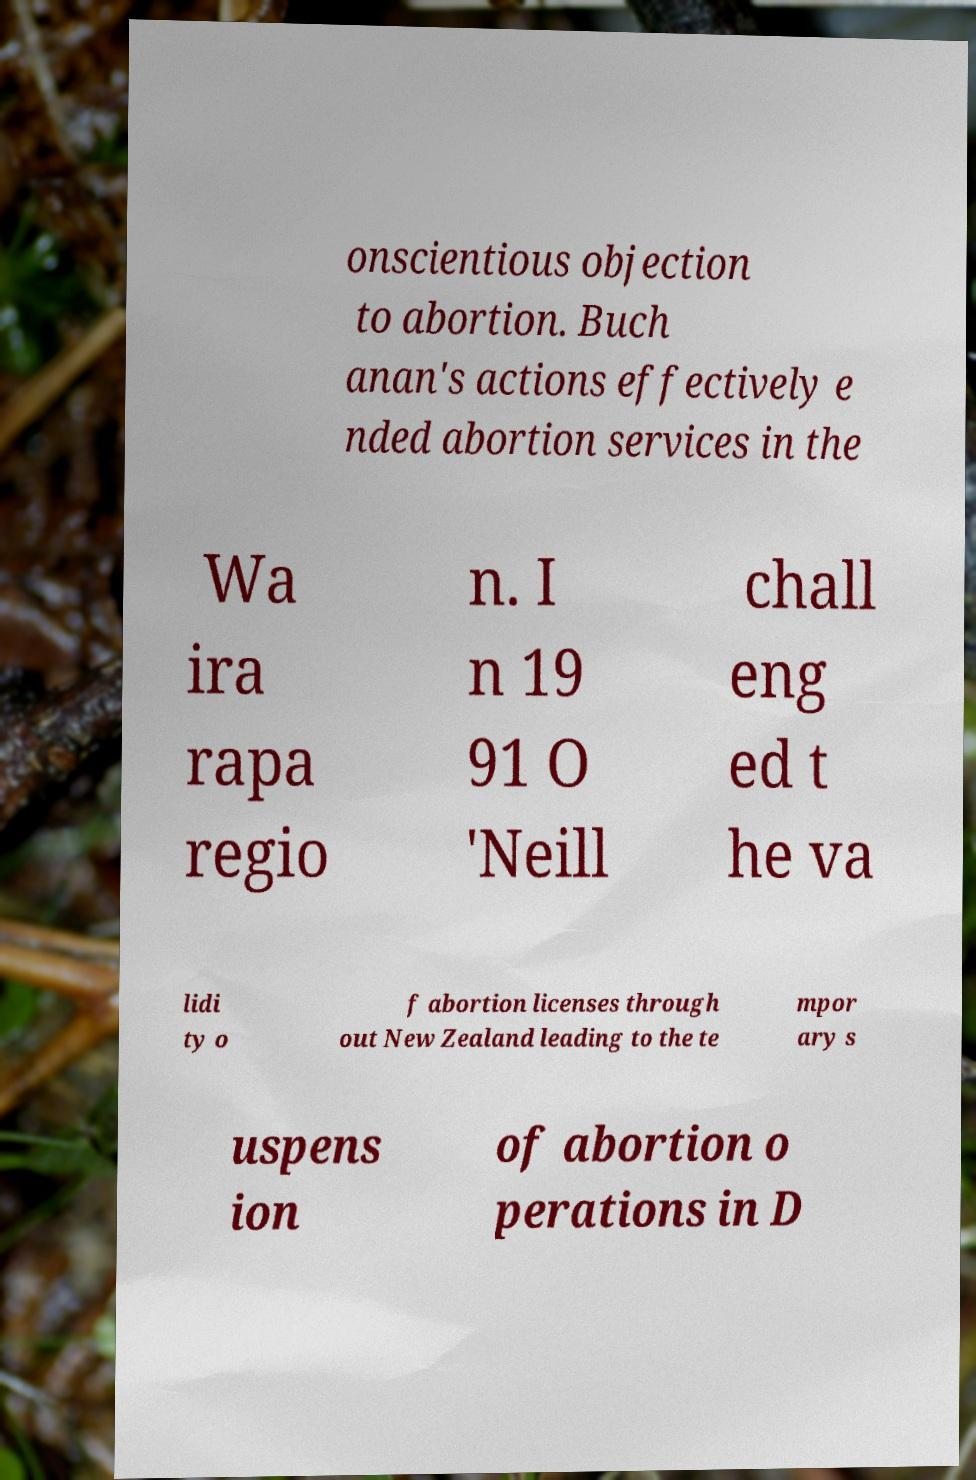What messages or text are displayed in this image? I need them in a readable, typed format. onscientious objection to abortion. Buch anan's actions effectively e nded abortion services in the Wa ira rapa regio n. I n 19 91 O 'Neill chall eng ed t he va lidi ty o f abortion licenses through out New Zealand leading to the te mpor ary s uspens ion of abortion o perations in D 